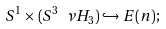Convert formula to latex. <formula><loc_0><loc_0><loc_500><loc_500>S ^ { 1 } \times ( S ^ { 3 } \ \nu H _ { 3 } ) \hookrightarrow E ( n ) ;</formula> 